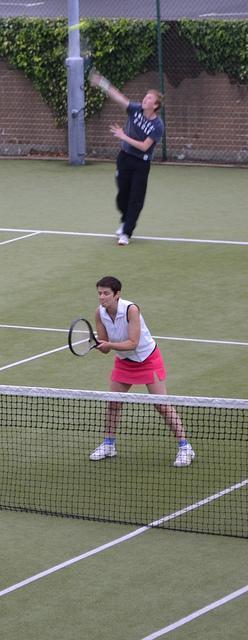How many people are there?
Give a very brief answer. 2. 